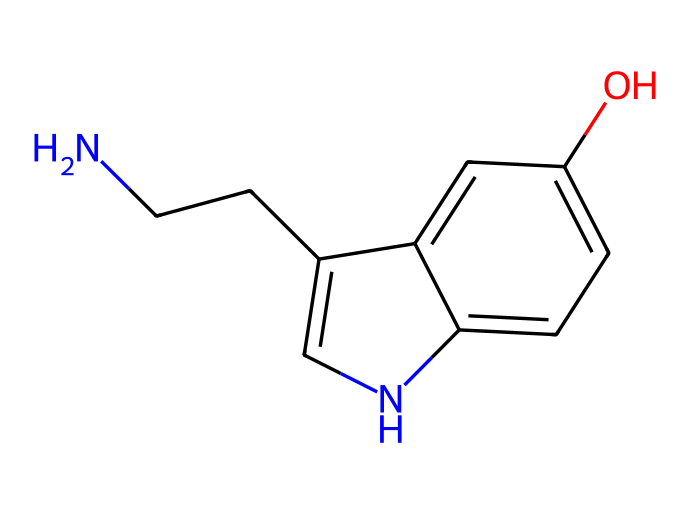What is the molecular formula of serotonin? By analyzing the chemical structure from the provided SMILES representation, we can count the atoms present. The SMILES indicates 10 carbon atoms, 12 hydrogen atoms, 1 nitrogen atom, and 1 oxygen atom. Therefore, the molecular formula can be derived as C10H12N2O.
Answer: C10H12N2O How many rings are present in serotonin? The SMILES structure shows that there are two connected cyclic portions, which can be identified as one five-membered ring and one six-membered ring. Hence, there are two rings present in the overall structure.
Answer: 2 What type of functional groups are present in serotonin? The structure contains a hydroxyl group (-OH) visible in the aromatic ring, and an amine group (-NH) connected to the ethyl chain. These are the functional groups identifiable in this chemical structure.
Answer: hydroxyl and amine What type of hybridization is present in the nitrogen atom? Analyzing the nitrogen atom in serotonin, we note that it is bonded to two carbon atoms and is involved in a protonated amine state which indicates sp3 hybridization due to the presence of four regions of electron density.
Answer: sp3 How many total atoms are there in serotonin? Counting all atoms present in the final molecular formula (C10H12N2O), we see there are 10 Carbons, 12 Hydrogens, 2 Nitrogens, and 1 Oxygen, which totals to 25 atoms overall in the compound.
Answer: 25 Which part of the serotonin molecule participates in hydrogen bonding? By examining the structure, the hydroxyl group (-OH) is involved in hydrogen bonding due to the presence of a highly electronegative oxygen atom bonded to hydrogen, allowing it to interact with other polar molecules or functional groups.
Answer: hydroxyl group 